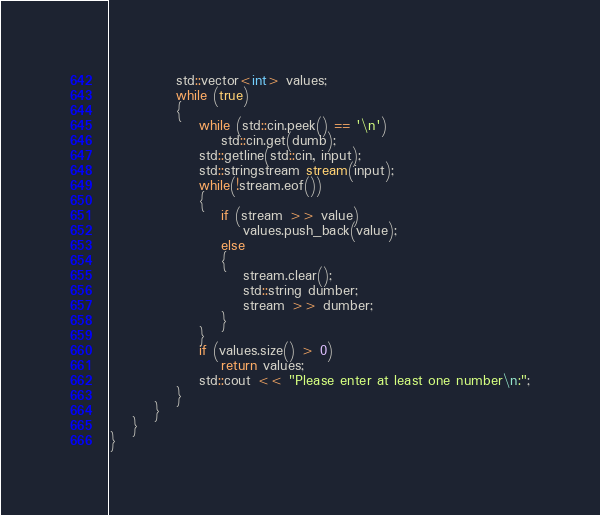<code> <loc_0><loc_0><loc_500><loc_500><_Cuda_>            std::vector<int> values;
            while (true)
            {
                while (std::cin.peek() == '\n')
                    std::cin.get(dumb);
                std::getline(std::cin, input);
                std::stringstream stream(input);
                while(!stream.eof())
                {
                    if (stream >> value)
                        values.push_back(value);
                    else
                    {
                        stream.clear();
                        std::string dumber;
                        stream >> dumber;
                    }
                }
                if (values.size() > 0)
                    return values;
                std::cout << "Please enter at least one number\n:";
            }
        }       
    }
}
</code> 